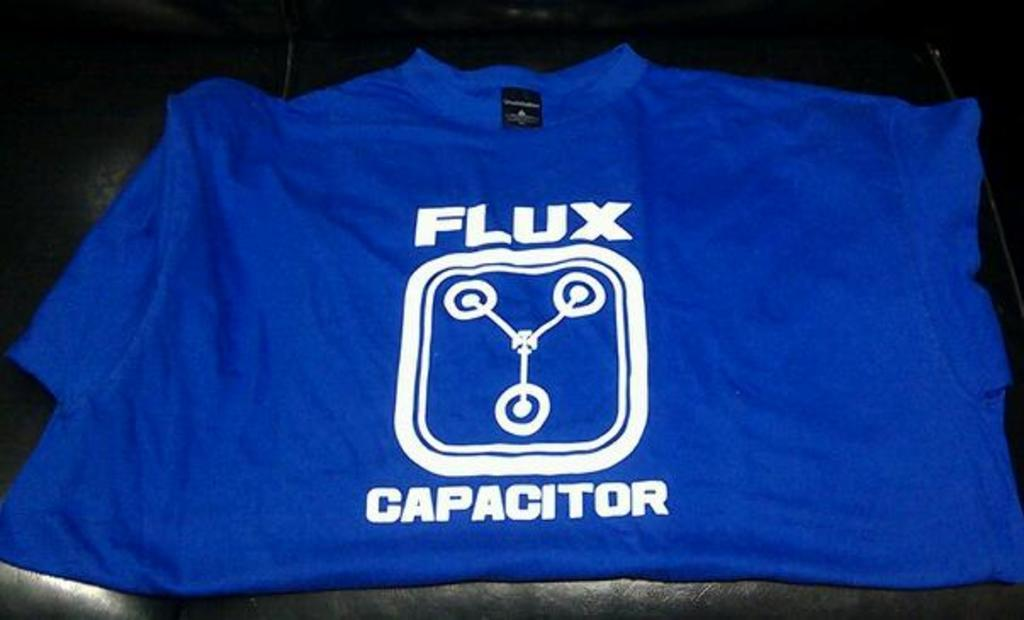<image>
Relay a brief, clear account of the picture shown. A blue flux capacitor tee shirt is folded on a table. 